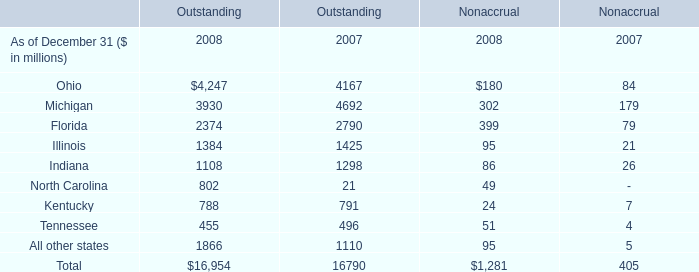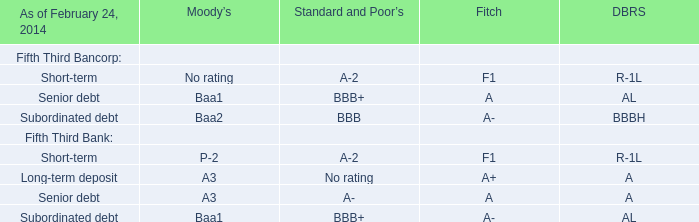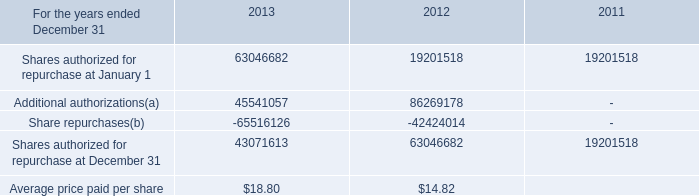what's the total amount of Illinois of Outstanding 2007, Share repurchases of 2012, and Michigan of Outstanding 2007 ? 
Computations: ((1425.0 + 42424014.0) + 4692.0)
Answer: 42430131.0. 